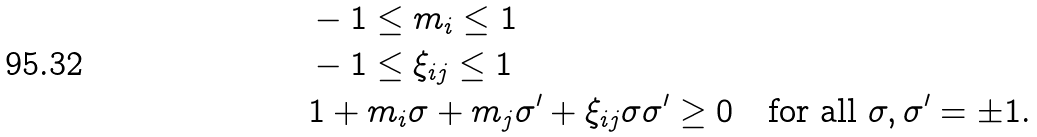<formula> <loc_0><loc_0><loc_500><loc_500>& - 1 \leq m _ { i } \leq 1 \\ & - 1 \leq \xi _ { i j } \leq 1 \\ & 1 + m _ { i } \sigma + m _ { j } \sigma ^ { \prime } + \xi _ { i j } \sigma \sigma ^ { \prime } \geq 0 \quad \text {for all $\sigma, \sigma^{\prime}= \pm 1$.}</formula> 